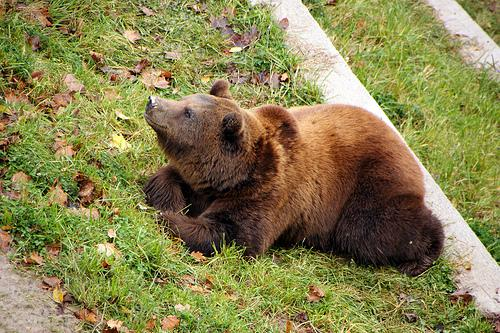Question: where is this picture taken?
Choices:
A. Near a cub.
B. Near a grizzly.
C. Near bear.
D. Near a tiger.
Answer with the letter. Answer: C Question: what kind of animal is pictured?
Choices:
A. Squirrel.
B. Duck.
C. Bird.
D. Bear.
Answer with the letter. Answer: D Question: where is the bear facing, directionally?
Choices:
A. Right.
B. Forward.
C. Backwards.
D. Left.
Answer with the letter. Answer: D Question: how many people are pictured?
Choices:
A. One.
B. Two.
C. None.
D. Three.
Answer with the letter. Answer: C Question: what color is the bear?
Choices:
A. Black.
B. White.
C. Yellow.
D. Brown.
Answer with the letter. Answer: D 